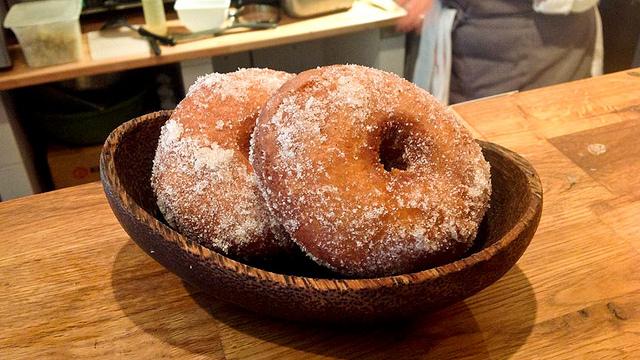Are the donuts in a bowl?
Give a very brief answer. Yes. What type of kitchen counter are the doughnuts in the bowl on?
Concise answer only. Wood. Are these donuts too sugary?
Concise answer only. Yes. 